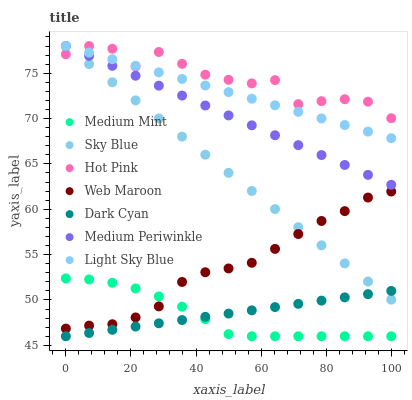Does Medium Mint have the minimum area under the curve?
Answer yes or no. Yes. Does Hot Pink have the maximum area under the curve?
Answer yes or no. Yes. Does Medium Periwinkle have the minimum area under the curve?
Answer yes or no. No. Does Medium Periwinkle have the maximum area under the curve?
Answer yes or no. No. Is Light Sky Blue the smoothest?
Answer yes or no. Yes. Is Hot Pink the roughest?
Answer yes or no. Yes. Is Medium Periwinkle the smoothest?
Answer yes or no. No. Is Medium Periwinkle the roughest?
Answer yes or no. No. Does Medium Mint have the lowest value?
Answer yes or no. Yes. Does Medium Periwinkle have the lowest value?
Answer yes or no. No. Does Sky Blue have the highest value?
Answer yes or no. Yes. Does Web Maroon have the highest value?
Answer yes or no. No. Is Dark Cyan less than Medium Periwinkle?
Answer yes or no. Yes. Is Web Maroon greater than Dark Cyan?
Answer yes or no. Yes. Does Hot Pink intersect Sky Blue?
Answer yes or no. Yes. Is Hot Pink less than Sky Blue?
Answer yes or no. No. Is Hot Pink greater than Sky Blue?
Answer yes or no. No. Does Dark Cyan intersect Medium Periwinkle?
Answer yes or no. No. 